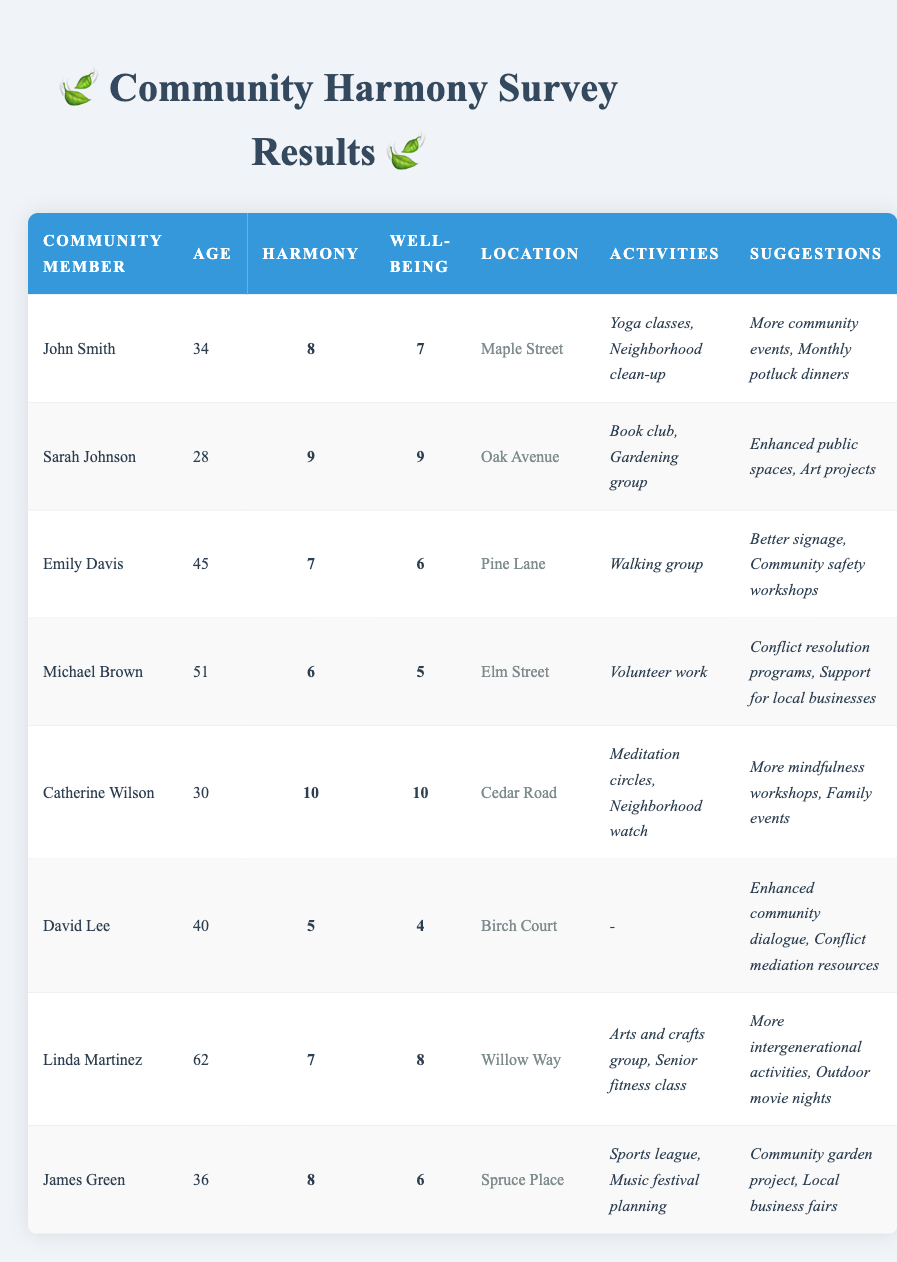What is the perception of harmony scored by Catherine Wilson? According to the table, Catherine Wilson has a perception of harmony score of 10.
Answer: 10 How many community members have a well-being score of 8 or higher? From the table, the members with a well-being score of 8 or higher are Sarah Johnson (9), Catherine Wilson (10), and Linda Martinez (8), which totals to 3 community members.
Answer: 3 What is the location of David Lee? The table lists David Lee's location as Birch Court.
Answer: Birch Court What suggestions for improvement did Michael Brown provide? In the table, Michael Brown suggested "Conflict resolution programs" and "Support for local businesses" as improvements.
Answer: Conflict resolution programs, Support for local businesses What is the average perception of harmony among all community members? To calculate the average, we sum the perception scores: 8 + 9 + 7 + 6 + 10 + 5 + 7 + 8 = 60. There are 8 members, so the average is 60/8 = 7.5.
Answer: 7.5 Is there any community member who is not engaged in any activities? Yes, the table shows that David Lee does not engage in any community activities.
Answer: Yes Who has the lowest well-being score, and what is that score? David Lee has the lowest well-being score, which is 4, as indicated in the table.
Answer: 4 Which community member has the highest perception of harmony and well-being? Catherine Wilson has the highest scores in both categories: a perception of harmony of 10 and a well-being score of 10.
Answer: Catherine Wilson How many community members are engaged in the "Yoga classes"? The table lists one community member, John Smith, as engaging in "Yoga classes."
Answer: 1 What is the difference between the highest and lowest perception of harmony scores in the community? The highest score is 10 (Catherine Wilson) and the lowest is 5 (David Lee). The difference is 10 - 5 = 5.
Answer: 5 Which age group predominantly perceives harmony above 8? The members scoring above 8 are Sarah Johnson (28), Catherine Wilson (30), and John Smith (34), indicating that the age group of 28-34 perceives harmony above 8.
Answer: 28-34 